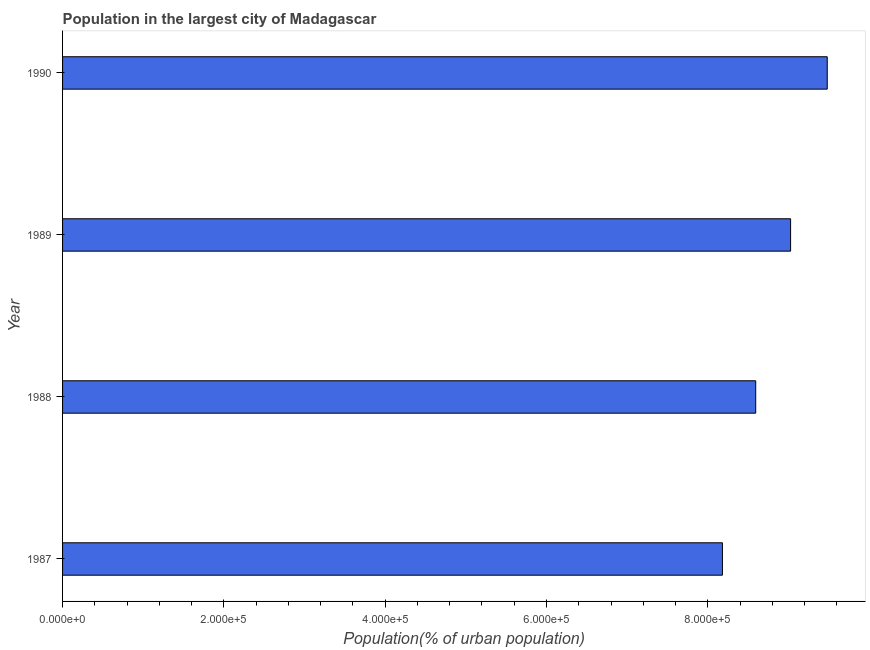Does the graph contain any zero values?
Your answer should be very brief. No. What is the title of the graph?
Provide a succinct answer. Population in the largest city of Madagascar. What is the label or title of the X-axis?
Ensure brevity in your answer.  Population(% of urban population). What is the population in largest city in 1988?
Keep it short and to the point. 8.59e+05. Across all years, what is the maximum population in largest city?
Provide a short and direct response. 9.48e+05. Across all years, what is the minimum population in largest city?
Offer a terse response. 8.18e+05. In which year was the population in largest city maximum?
Keep it short and to the point. 1990. What is the sum of the population in largest city?
Provide a short and direct response. 3.53e+06. What is the difference between the population in largest city in 1987 and 1989?
Your answer should be very brief. -8.45e+04. What is the average population in largest city per year?
Your response must be concise. 8.82e+05. What is the median population in largest city?
Your response must be concise. 8.81e+05. What is the difference between the highest and the second highest population in largest city?
Your response must be concise. 4.55e+04. Is the sum of the population in largest city in 1987 and 1989 greater than the maximum population in largest city across all years?
Keep it short and to the point. Yes. What is the difference between the highest and the lowest population in largest city?
Keep it short and to the point. 1.30e+05. In how many years, is the population in largest city greater than the average population in largest city taken over all years?
Offer a terse response. 2. Are all the bars in the graph horizontal?
Provide a succinct answer. Yes. What is the difference between two consecutive major ticks on the X-axis?
Offer a very short reply. 2.00e+05. What is the Population(% of urban population) of 1987?
Provide a succinct answer. 8.18e+05. What is the Population(% of urban population) of 1988?
Offer a terse response. 8.59e+05. What is the Population(% of urban population) of 1989?
Your answer should be compact. 9.03e+05. What is the Population(% of urban population) in 1990?
Make the answer very short. 9.48e+05. What is the difference between the Population(% of urban population) in 1987 and 1988?
Your answer should be compact. -4.13e+04. What is the difference between the Population(% of urban population) in 1987 and 1989?
Offer a very short reply. -8.45e+04. What is the difference between the Population(% of urban population) in 1987 and 1990?
Give a very brief answer. -1.30e+05. What is the difference between the Population(% of urban population) in 1988 and 1989?
Your response must be concise. -4.32e+04. What is the difference between the Population(% of urban population) in 1988 and 1990?
Make the answer very short. -8.87e+04. What is the difference between the Population(% of urban population) in 1989 and 1990?
Offer a very short reply. -4.55e+04. What is the ratio of the Population(% of urban population) in 1987 to that in 1988?
Give a very brief answer. 0.95. What is the ratio of the Population(% of urban population) in 1987 to that in 1989?
Ensure brevity in your answer.  0.91. What is the ratio of the Population(% of urban population) in 1987 to that in 1990?
Keep it short and to the point. 0.86. What is the ratio of the Population(% of urban population) in 1988 to that in 1989?
Offer a terse response. 0.95. What is the ratio of the Population(% of urban population) in 1988 to that in 1990?
Give a very brief answer. 0.91. What is the ratio of the Population(% of urban population) in 1989 to that in 1990?
Your response must be concise. 0.95. 